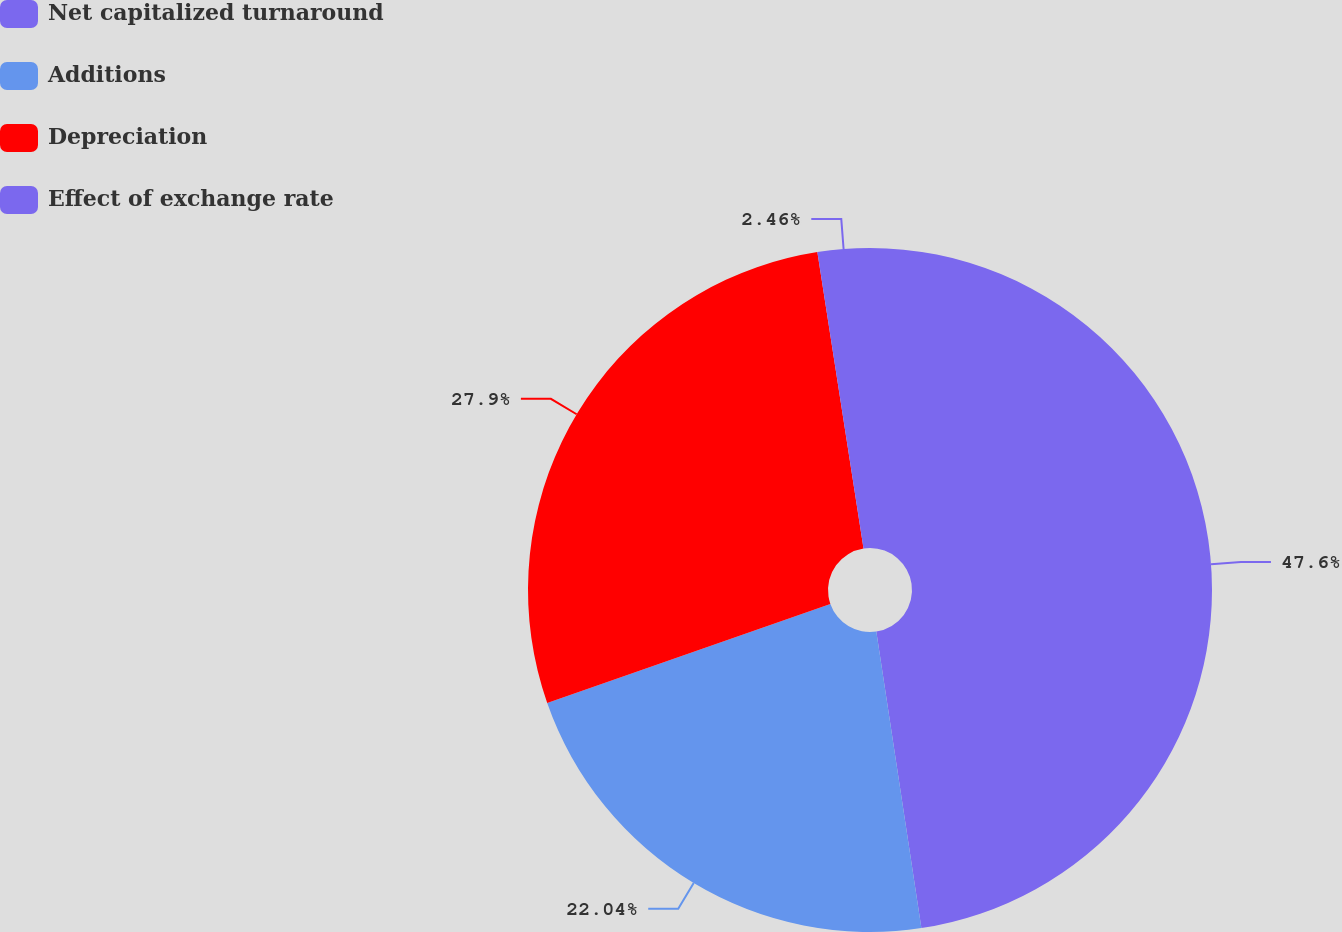<chart> <loc_0><loc_0><loc_500><loc_500><pie_chart><fcel>Net capitalized turnaround<fcel>Additions<fcel>Depreciation<fcel>Effect of exchange rate<nl><fcel>47.6%<fcel>22.04%<fcel>27.9%<fcel>2.46%<nl></chart> 